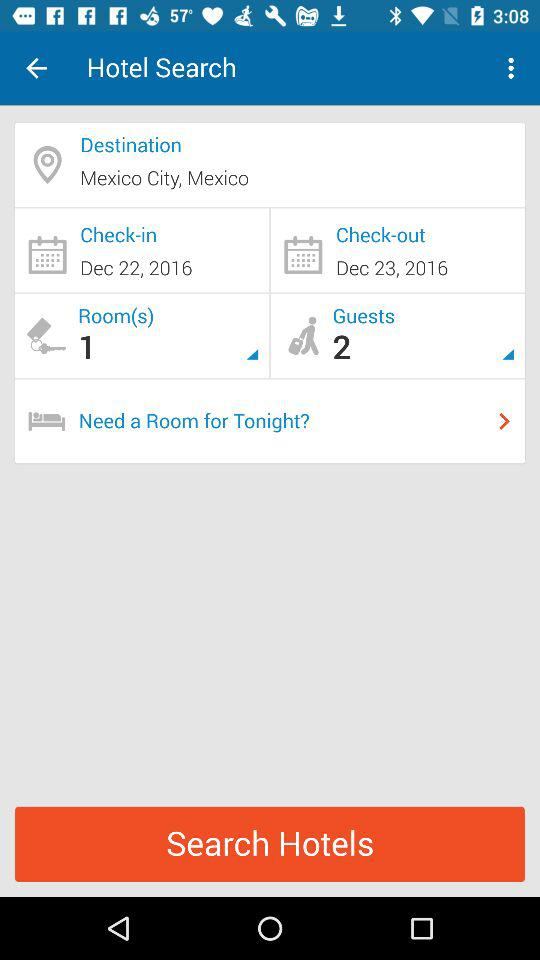What is the destination? The destination is Mexico City, Mexico. 